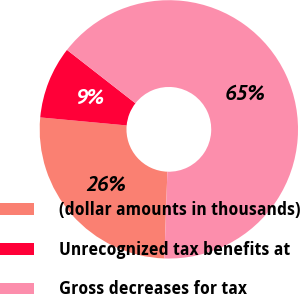Convert chart to OTSL. <chart><loc_0><loc_0><loc_500><loc_500><pie_chart><fcel>(dollar amounts in thousands)<fcel>Unrecognized tax benefits at<fcel>Gross decreases for tax<nl><fcel>25.92%<fcel>9.07%<fcel>65.01%<nl></chart> 